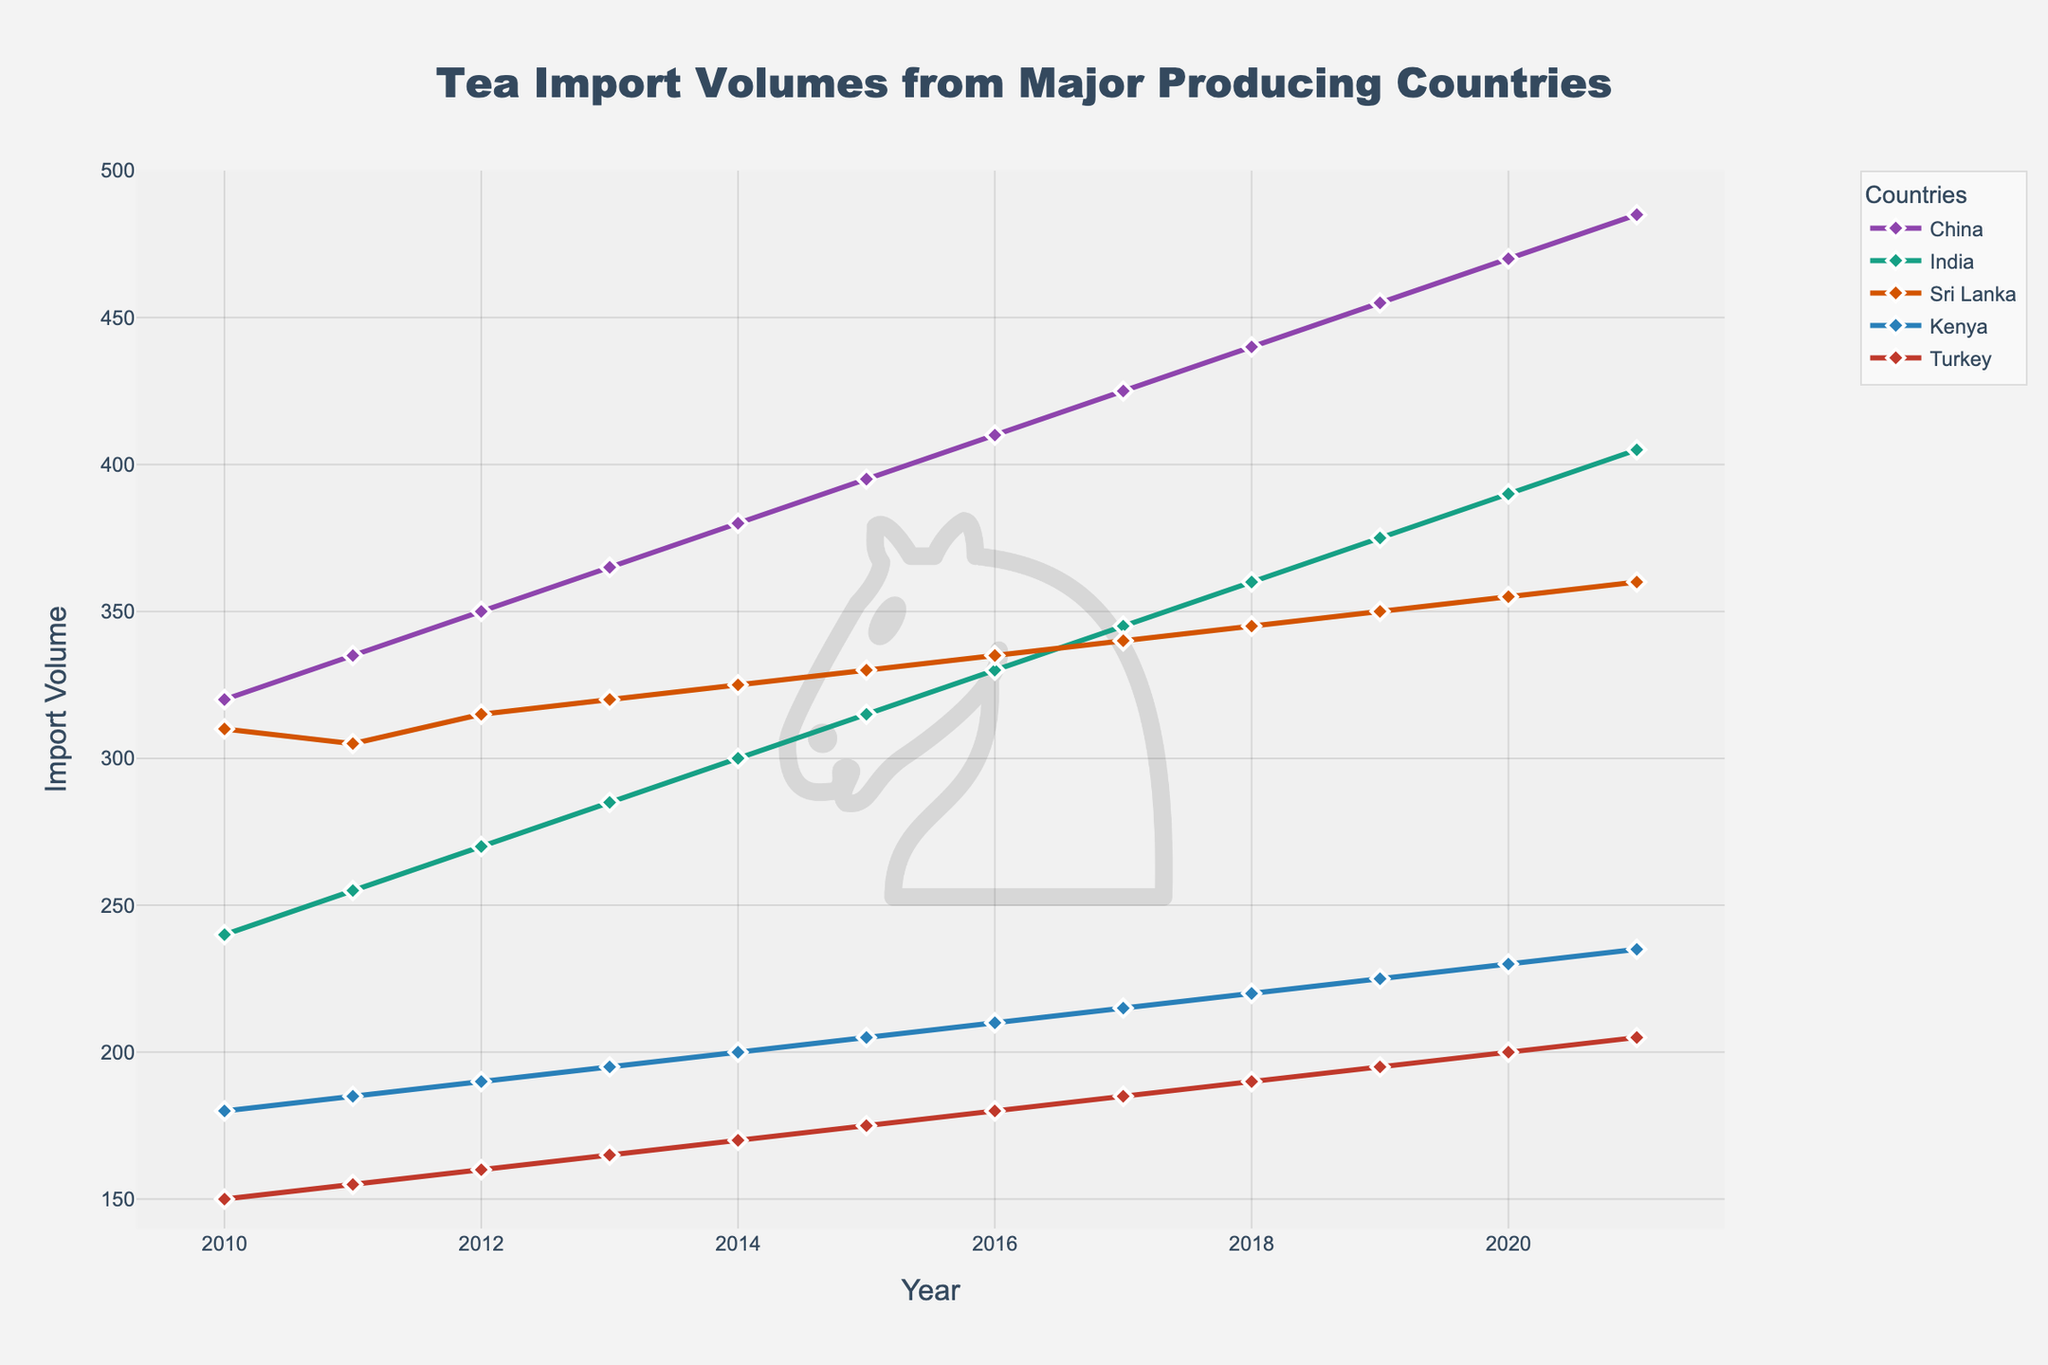What is the range of tea import volumes from China over the years? The range is obtained by subtracting the lowest import volume from China (320 in 2010) from the highest import volume from China (485 in 2021).
Answer: 165 Which country had the lowest import volume in 2021 and what was it? Looking at the end points of all lines in 2021, Turkey had the lowest import volume of 205.
Answer: Turkey, 205 Between which consecutive years did Sri Lanka see the highest increase in import volumes? Calculate the yearly differences for Sri Lanka and find the maximum difference. The highest increase occurred between 2010 and 2011, where import volume increased from 310 to 305.
Answer: 2010-2011 Which country's import volume was consistently increasing every year? By observing the trends of each line, China’s import volumes show a consistent increase every year from 2010 to 2021.
Answer: China In which year did Kenya's import volume surpass 200 for the first time? Following the trend line for Kenya, we see that it surpasses 200 for the first time in 2014.
Answer: 2014 Which two countries had the closest import volumes in 2015, and what were the volumes? By comparing the points for each country in 2015, Sri Lanka and Kenya had the closest import volumes, both around 330.
Answer: Sri Lanka and Kenya, both around 330 What was the combined import volume of India and Turkey in 2013? Add the import volumes of India (285) and Turkey (165) for 2013. The combined volume is 450.
Answer: 450 Which country's import volume had the steepest rise between 2019 and 2020? Calculate the differences between 2019 and 2020 for all countries. China had the steepest rise from 455 to 470, a difference of 15.
Answer: China Compare the average import volumes of China and India over the entire period. Which country had a higher average, and by how much? Calculate the average for both China (sum = 4475, count = 12, average = 373) and India (sum = 3620, count = 12, average = 302). The difference is 373 - 302 = 71.
Answer: China, by 71 How many years did Turkey have the lowest import volume compared to other countries? Inspect each year's data and determine for how many years Turkey had the lowest number. Turkey had the lowest volume for all years from 2010 to 2021.
Answer: 12 